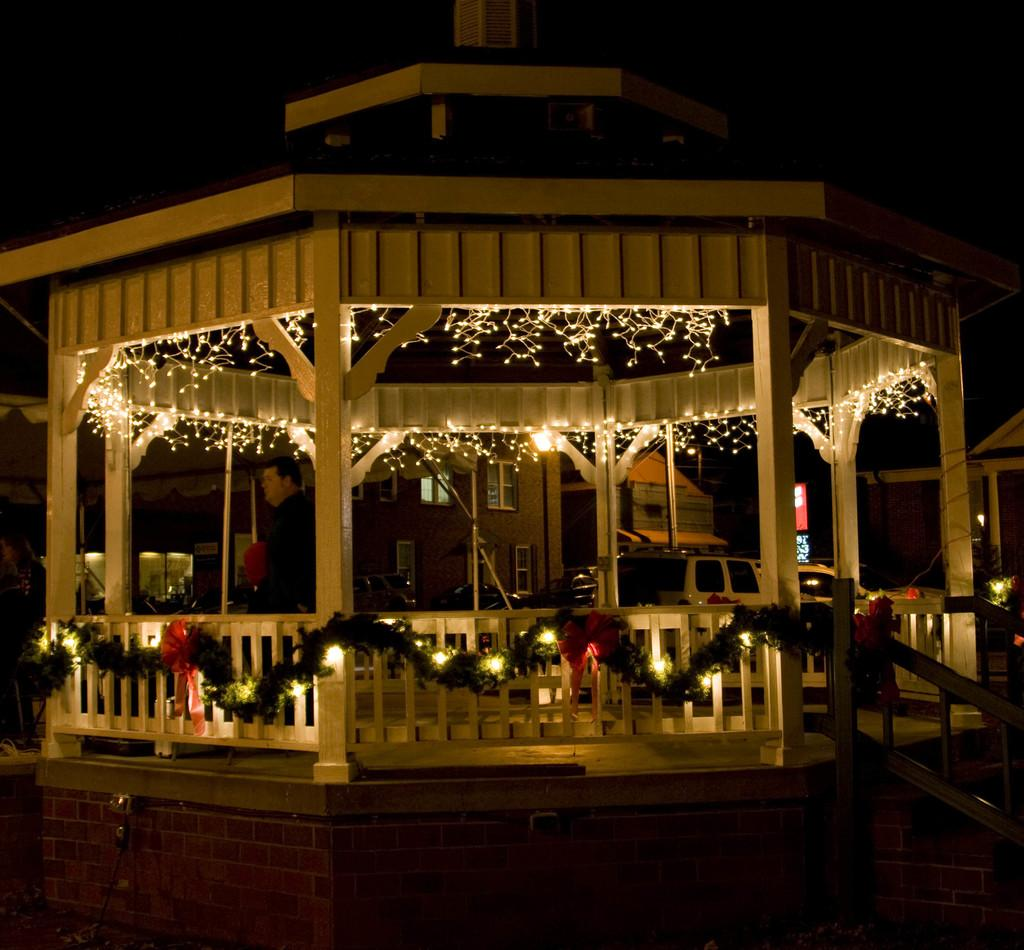What structure is the main focus of the image? There is a gazebo in the image. What feature can be seen inside the gazebo? There is lighting in the gazebo. What can be seen in the distance behind the gazebo? There are houses in the background of the image. What type of card is being used to cut the grass in the image? There is no card or grass cutting activity present in the image. Can you see any blades attached to the gazebo in the image? There are no blades attached to the gazebo in the image. 